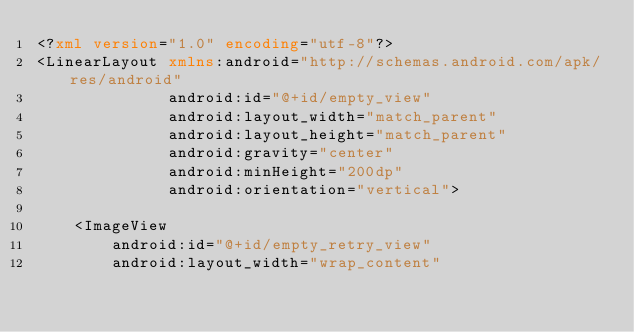Convert code to text. <code><loc_0><loc_0><loc_500><loc_500><_XML_><?xml version="1.0" encoding="utf-8"?>
<LinearLayout xmlns:android="http://schemas.android.com/apk/res/android"
              android:id="@+id/empty_view"
              android:layout_width="match_parent"
              android:layout_height="match_parent"
              android:gravity="center"
              android:minHeight="200dp"
              android:orientation="vertical">

    <ImageView
        android:id="@+id/empty_retry_view"
        android:layout_width="wrap_content"</code> 